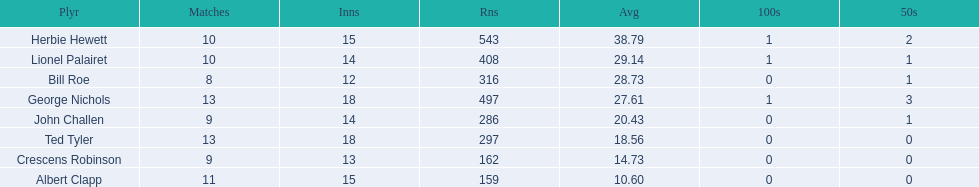How many players played more than 10 matches? 3. 